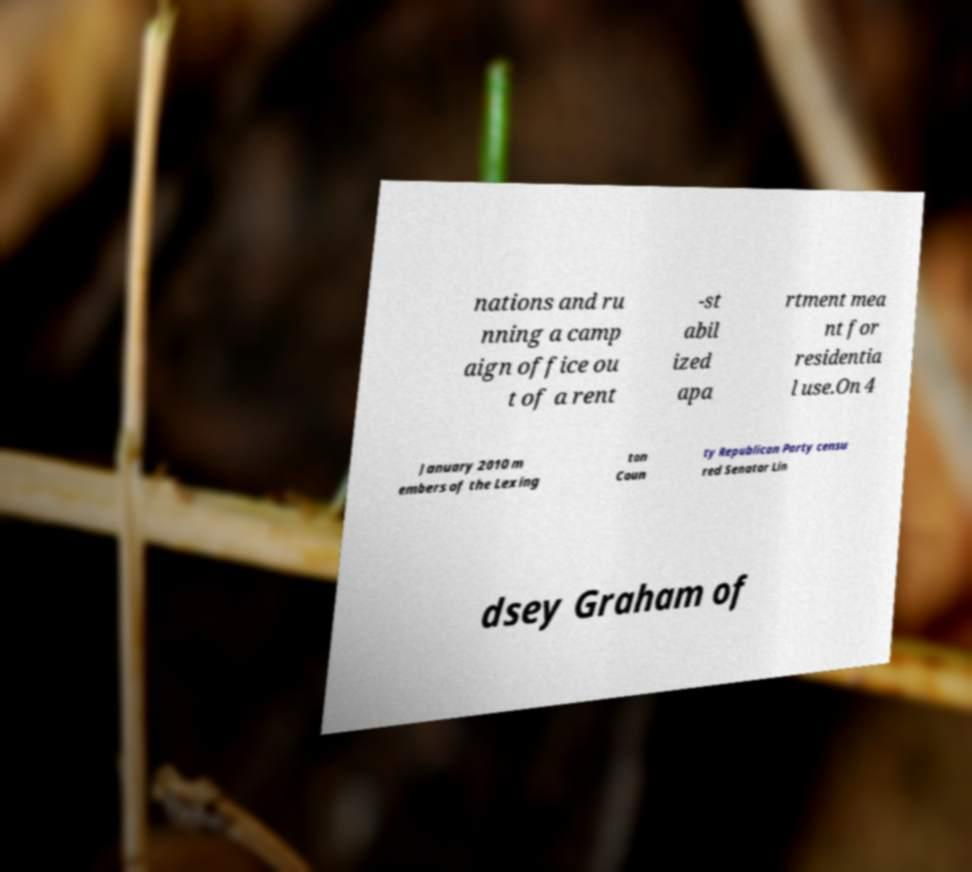Please identify and transcribe the text found in this image. nations and ru nning a camp aign office ou t of a rent -st abil ized apa rtment mea nt for residentia l use.On 4 January 2010 m embers of the Lexing ton Coun ty Republican Party censu red Senator Lin dsey Graham of 